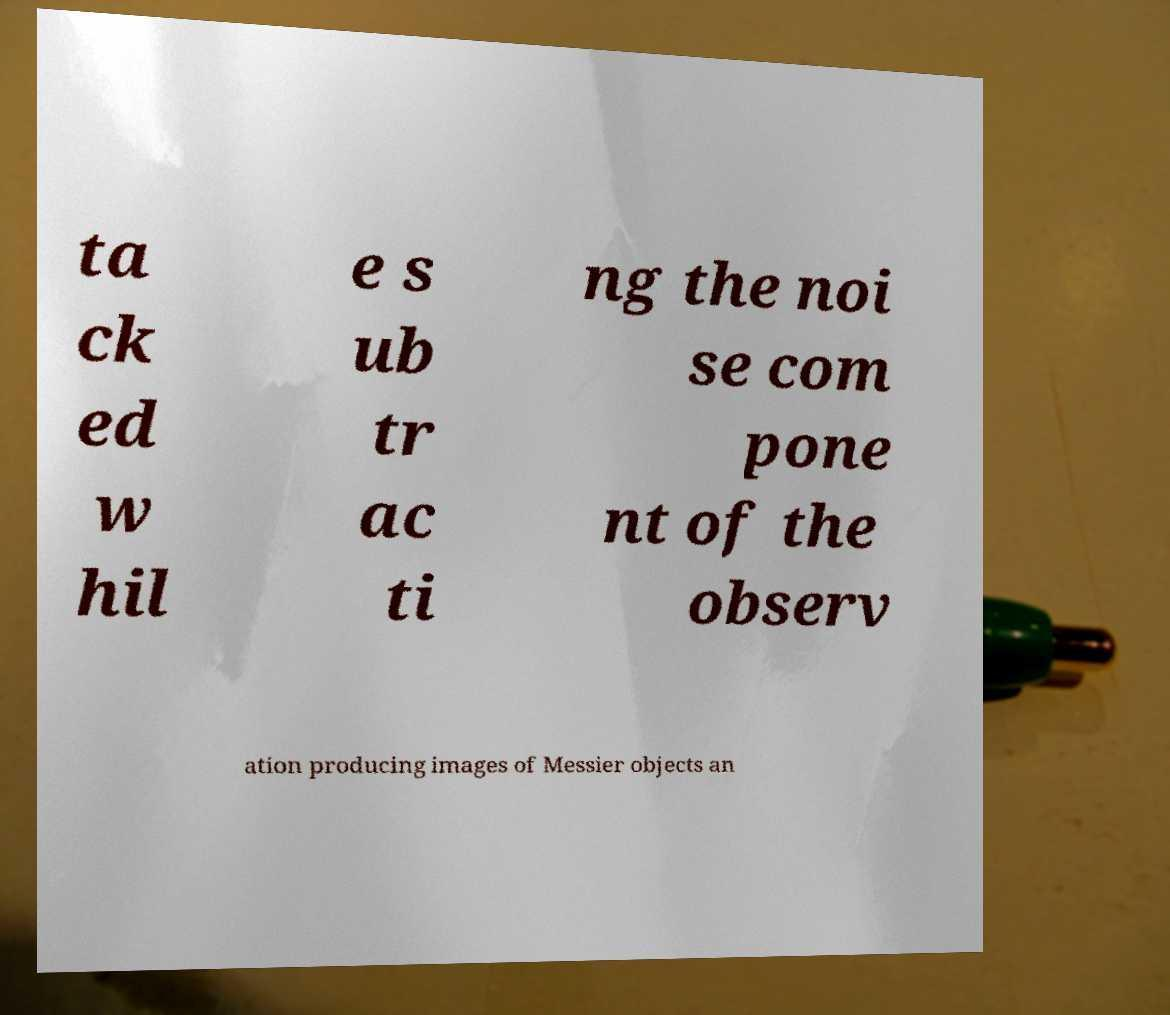Can you read and provide the text displayed in the image?This photo seems to have some interesting text. Can you extract and type it out for me? ta ck ed w hil e s ub tr ac ti ng the noi se com pone nt of the observ ation producing images of Messier objects an 